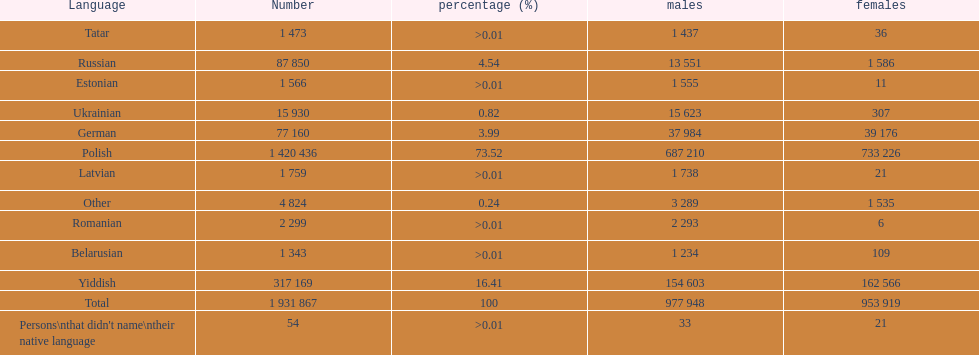Is german above or below russia in the number of people who speak that language? Below. 